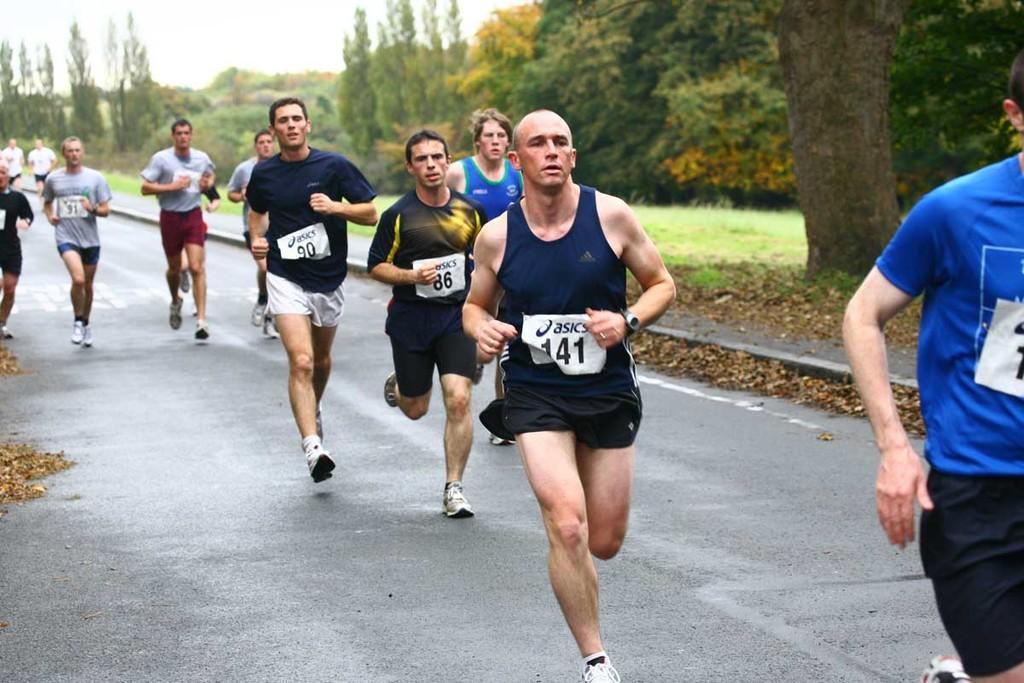Describe this image in one or two sentences. These people are running on the road. Background tree and grass. 